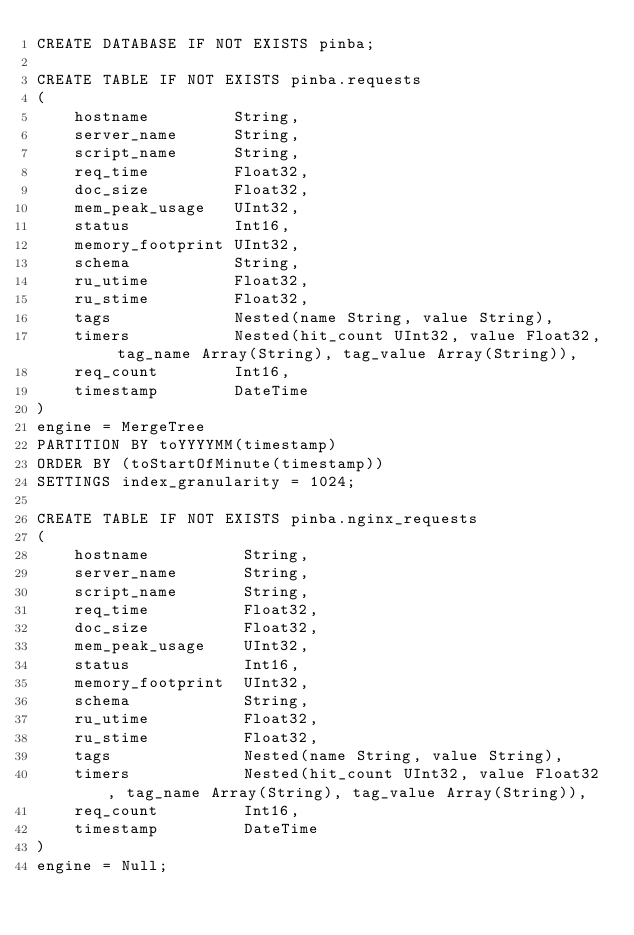<code> <loc_0><loc_0><loc_500><loc_500><_SQL_>CREATE DATABASE IF NOT EXISTS pinba;

CREATE TABLE IF NOT EXISTS pinba.requests
(
    hostname         String,
    server_name      String,
    script_name      String,
    req_time         Float32,
    doc_size         Float32,
    mem_peak_usage   UInt32,
    status           Int16,
    memory_footprint UInt32,
    schema           String,
    ru_utime         Float32,
    ru_stime         Float32,
    tags             Nested(name String, value String),
    timers           Nested(hit_count UInt32, value Float32, tag_name Array(String), tag_value Array(String)),
    req_count        Int16,
    timestamp        DateTime
)
engine = MergeTree
PARTITION BY toYYYYMM(timestamp)
ORDER BY (toStartOfMinute(timestamp))
SETTINGS index_granularity = 1024;

CREATE TABLE IF NOT EXISTS pinba.nginx_requests
(
    hostname          String,
    server_name       String,
    script_name       String,
    req_time          Float32,
    doc_size          Float32,
    mem_peak_usage    UInt32,
    status            Int16,
    memory_footprint  UInt32,
    schema            String,
    ru_utime          Float32,
    ru_stime          Float32,
    tags              Nested(name String, value String),
    timers            Nested(hit_count UInt32, value Float32, tag_name Array(String), tag_value Array(String)),
    req_count         Int16,
    timestamp         DateTime
)
engine = Null;</code> 